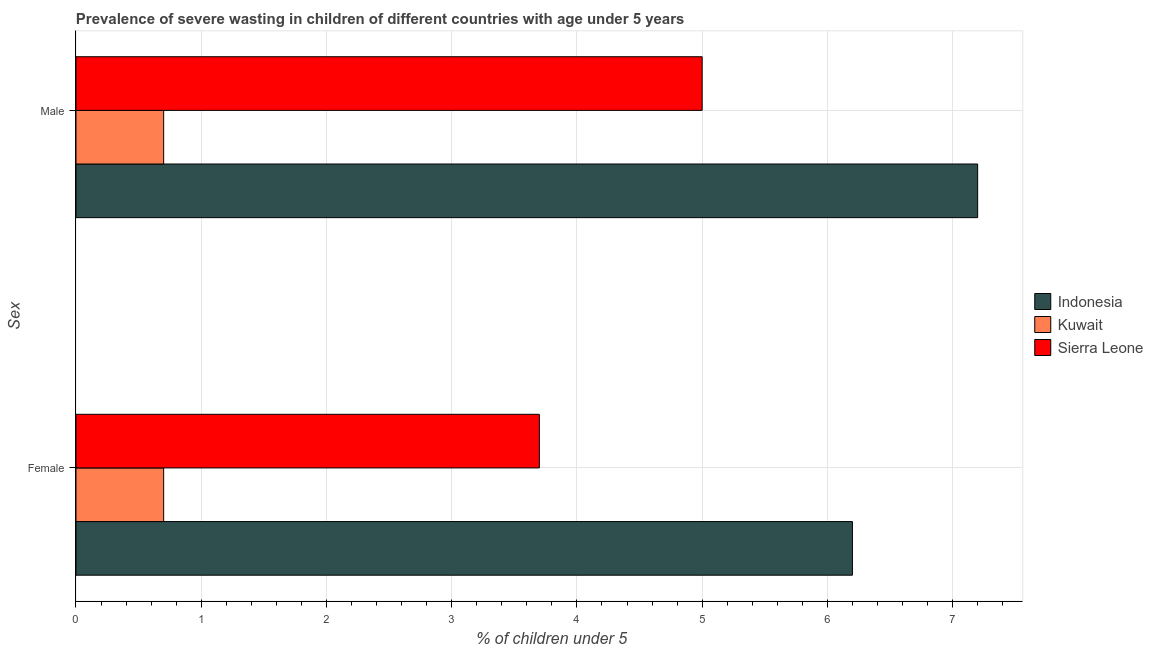How many different coloured bars are there?
Keep it short and to the point. 3. Are the number of bars per tick equal to the number of legend labels?
Make the answer very short. Yes. How many bars are there on the 2nd tick from the bottom?
Ensure brevity in your answer.  3. What is the percentage of undernourished male children in Kuwait?
Offer a very short reply. 0.7. Across all countries, what is the maximum percentage of undernourished male children?
Provide a short and direct response. 7.2. Across all countries, what is the minimum percentage of undernourished female children?
Provide a succinct answer. 0.7. In which country was the percentage of undernourished male children maximum?
Your answer should be compact. Indonesia. In which country was the percentage of undernourished female children minimum?
Ensure brevity in your answer.  Kuwait. What is the total percentage of undernourished male children in the graph?
Keep it short and to the point. 12.9. What is the difference between the percentage of undernourished male children in Kuwait and that in Indonesia?
Keep it short and to the point. -6.5. What is the difference between the percentage of undernourished male children in Kuwait and the percentage of undernourished female children in Sierra Leone?
Make the answer very short. -3. What is the average percentage of undernourished female children per country?
Provide a succinct answer. 3.53. What is the difference between the percentage of undernourished male children and percentage of undernourished female children in Kuwait?
Your answer should be very brief. 0. What is the ratio of the percentage of undernourished female children in Kuwait to that in Indonesia?
Your answer should be compact. 0.11. In how many countries, is the percentage of undernourished female children greater than the average percentage of undernourished female children taken over all countries?
Offer a terse response. 2. What does the 2nd bar from the top in Female represents?
Keep it short and to the point. Kuwait. What does the 3rd bar from the bottom in Female represents?
Give a very brief answer. Sierra Leone. What is the difference between two consecutive major ticks on the X-axis?
Make the answer very short. 1. Does the graph contain any zero values?
Keep it short and to the point. No. Where does the legend appear in the graph?
Offer a very short reply. Center right. How are the legend labels stacked?
Provide a succinct answer. Vertical. What is the title of the graph?
Your answer should be very brief. Prevalence of severe wasting in children of different countries with age under 5 years. What is the label or title of the X-axis?
Give a very brief answer.  % of children under 5. What is the label or title of the Y-axis?
Your answer should be compact. Sex. What is the  % of children under 5 in Indonesia in Female?
Your answer should be compact. 6.2. What is the  % of children under 5 in Kuwait in Female?
Provide a succinct answer. 0.7. What is the  % of children under 5 of Sierra Leone in Female?
Your response must be concise. 3.7. What is the  % of children under 5 of Indonesia in Male?
Your response must be concise. 7.2. What is the  % of children under 5 of Kuwait in Male?
Offer a terse response. 0.7. Across all Sex, what is the maximum  % of children under 5 in Indonesia?
Ensure brevity in your answer.  7.2. Across all Sex, what is the maximum  % of children under 5 of Kuwait?
Keep it short and to the point. 0.7. Across all Sex, what is the maximum  % of children under 5 in Sierra Leone?
Provide a succinct answer. 5. Across all Sex, what is the minimum  % of children under 5 in Indonesia?
Ensure brevity in your answer.  6.2. Across all Sex, what is the minimum  % of children under 5 in Kuwait?
Provide a short and direct response. 0.7. Across all Sex, what is the minimum  % of children under 5 in Sierra Leone?
Provide a short and direct response. 3.7. What is the total  % of children under 5 in Kuwait in the graph?
Ensure brevity in your answer.  1.4. What is the total  % of children under 5 of Sierra Leone in the graph?
Offer a terse response. 8.7. What is the difference between the  % of children under 5 of Kuwait in Female and that in Male?
Provide a short and direct response. 0. What is the difference between the  % of children under 5 of Sierra Leone in Female and that in Male?
Offer a terse response. -1.3. What is the difference between the  % of children under 5 of Indonesia in Female and the  % of children under 5 of Sierra Leone in Male?
Offer a terse response. 1.2. What is the difference between the  % of children under 5 in Kuwait in Female and the  % of children under 5 in Sierra Leone in Male?
Your answer should be compact. -4.3. What is the average  % of children under 5 of Indonesia per Sex?
Give a very brief answer. 6.7. What is the average  % of children under 5 of Sierra Leone per Sex?
Provide a short and direct response. 4.35. What is the difference between the  % of children under 5 in Indonesia and  % of children under 5 in Kuwait in Female?
Your answer should be compact. 5.5. What is the difference between the  % of children under 5 in Kuwait and  % of children under 5 in Sierra Leone in Female?
Your answer should be compact. -3. What is the ratio of the  % of children under 5 in Indonesia in Female to that in Male?
Your response must be concise. 0.86. What is the ratio of the  % of children under 5 of Sierra Leone in Female to that in Male?
Your answer should be compact. 0.74. What is the difference between the highest and the second highest  % of children under 5 of Kuwait?
Your answer should be very brief. 0. What is the difference between the highest and the lowest  % of children under 5 of Indonesia?
Your answer should be very brief. 1. What is the difference between the highest and the lowest  % of children under 5 in Kuwait?
Make the answer very short. 0. 